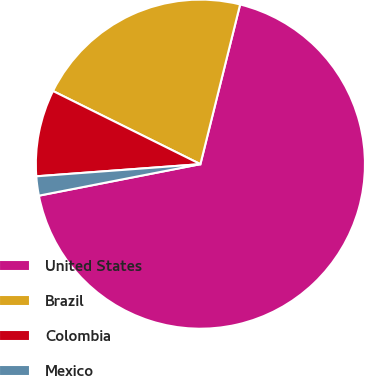Convert chart to OTSL. <chart><loc_0><loc_0><loc_500><loc_500><pie_chart><fcel>United States<fcel>Brazil<fcel>Colombia<fcel>Mexico<nl><fcel>68.06%<fcel>21.55%<fcel>8.51%<fcel>1.89%<nl></chart> 